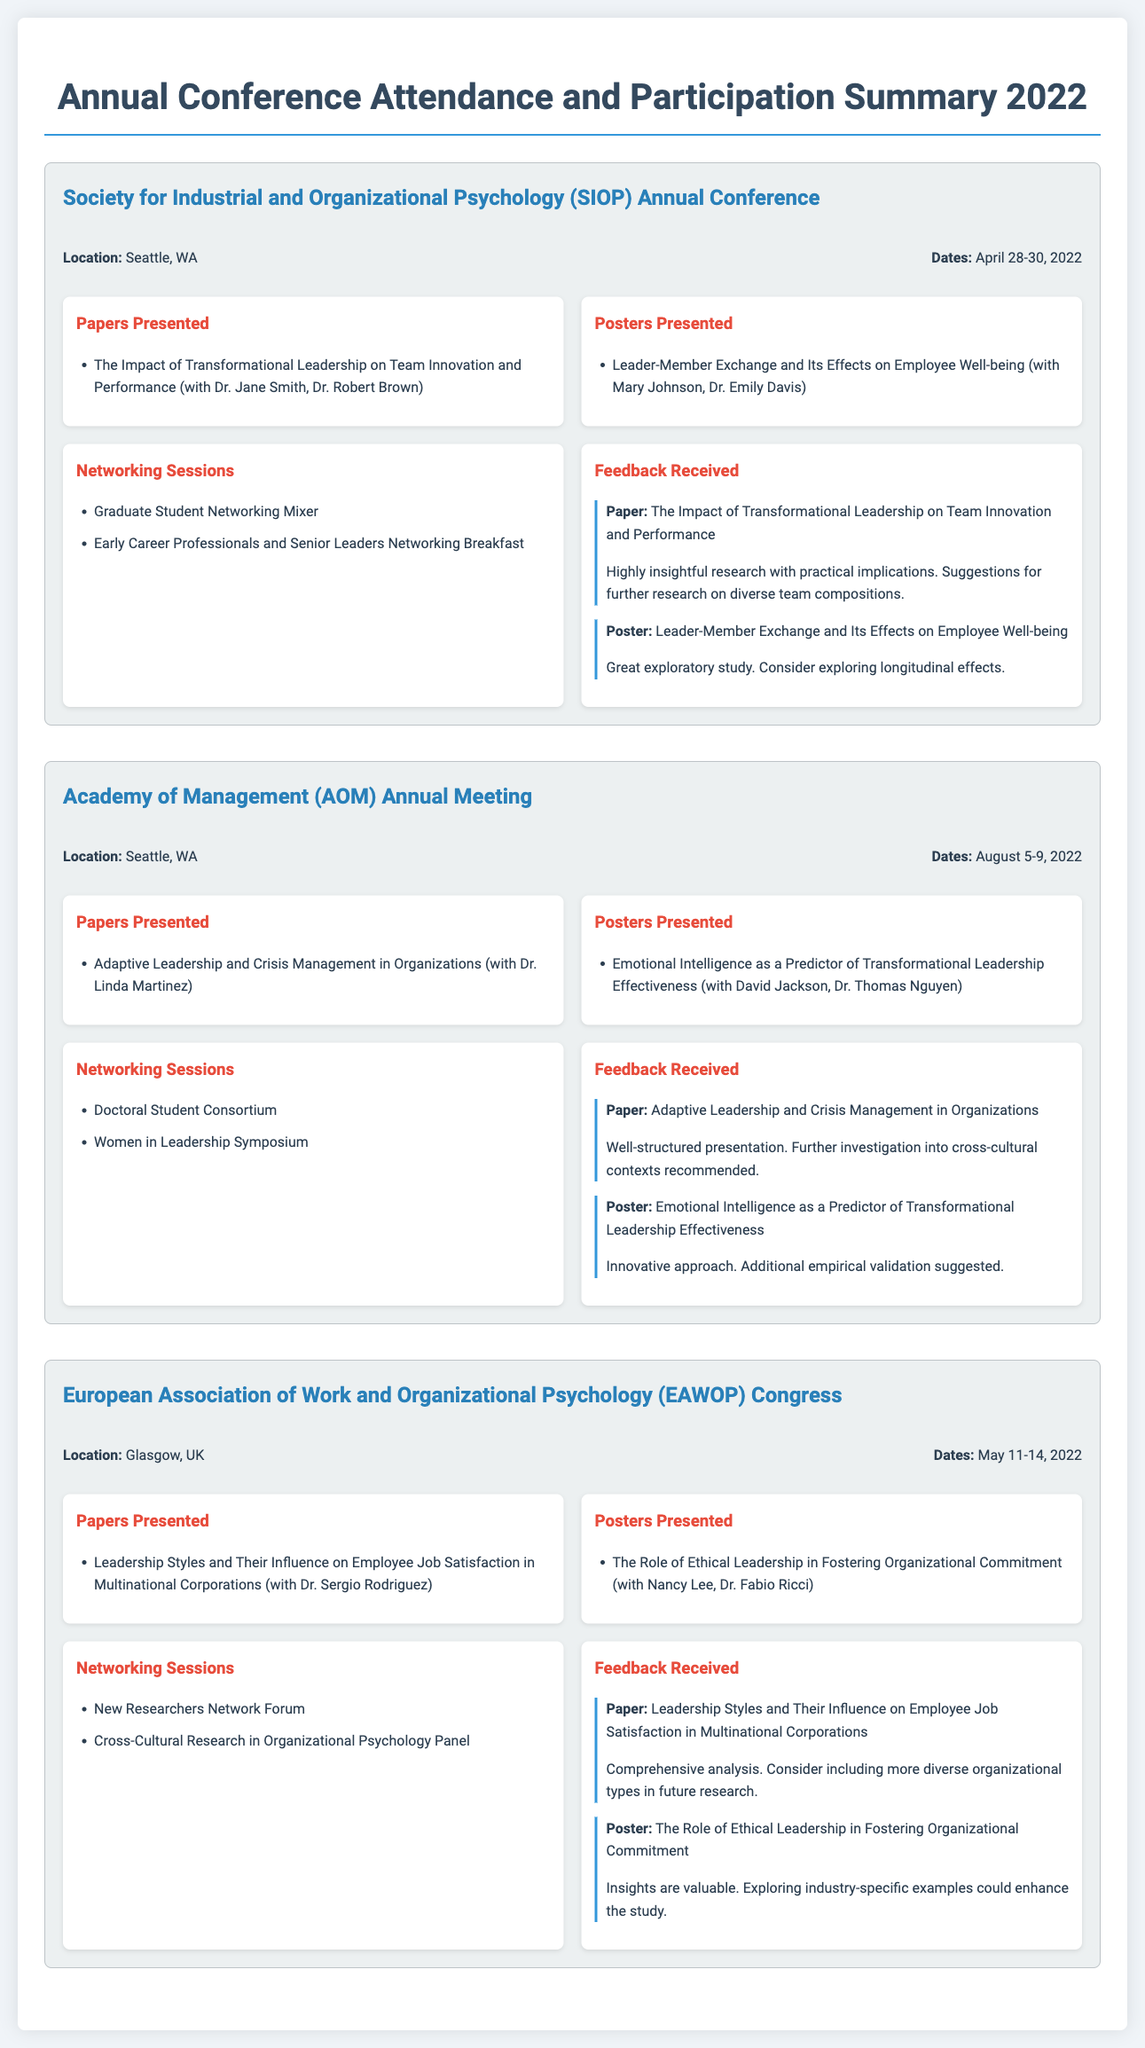What is the location of the SIOP Annual Conference? The location is indicated in the document under the conference details for SIOP.
Answer: Seattle, WA How many papers were presented at the AOM Annual Meeting? The document lists the papers presented under the AOM conference participation details.
Answer: 1 What was the title of the poster presented at EAWOP? The document specifies the title of the poster presented under the EAWOP participation details.
Answer: The Role of Ethical Leadership in Fostering Organizational Commitment Which networking session did participants attend at the SIOP conference? The networking sessions are detailed under the SIOP conference section.
Answer: Graduate Student Networking Mixer What feedback was provided for the paper on adaptive leadership? The feedback received is listed under the feedback section for the AOM conference.
Answer: Well-structured presentation. Further investigation into cross-cultural contexts recommended How many networking sessions were participated in at the EAWOP Congress? The document counts the networking sessions listed for the EAWOP participation details.
Answer: 2 What is the date range for the AOM Annual Meeting? The dates are presented in the conference details section for AOM.
Answer: August 5-9, 2022 Who co-authored the paper on the impact of transformational leadership? The document names the co-authors in the papers presented section for SIOP.
Answer: Dr. Jane Smith, Dr. Robert Brown 